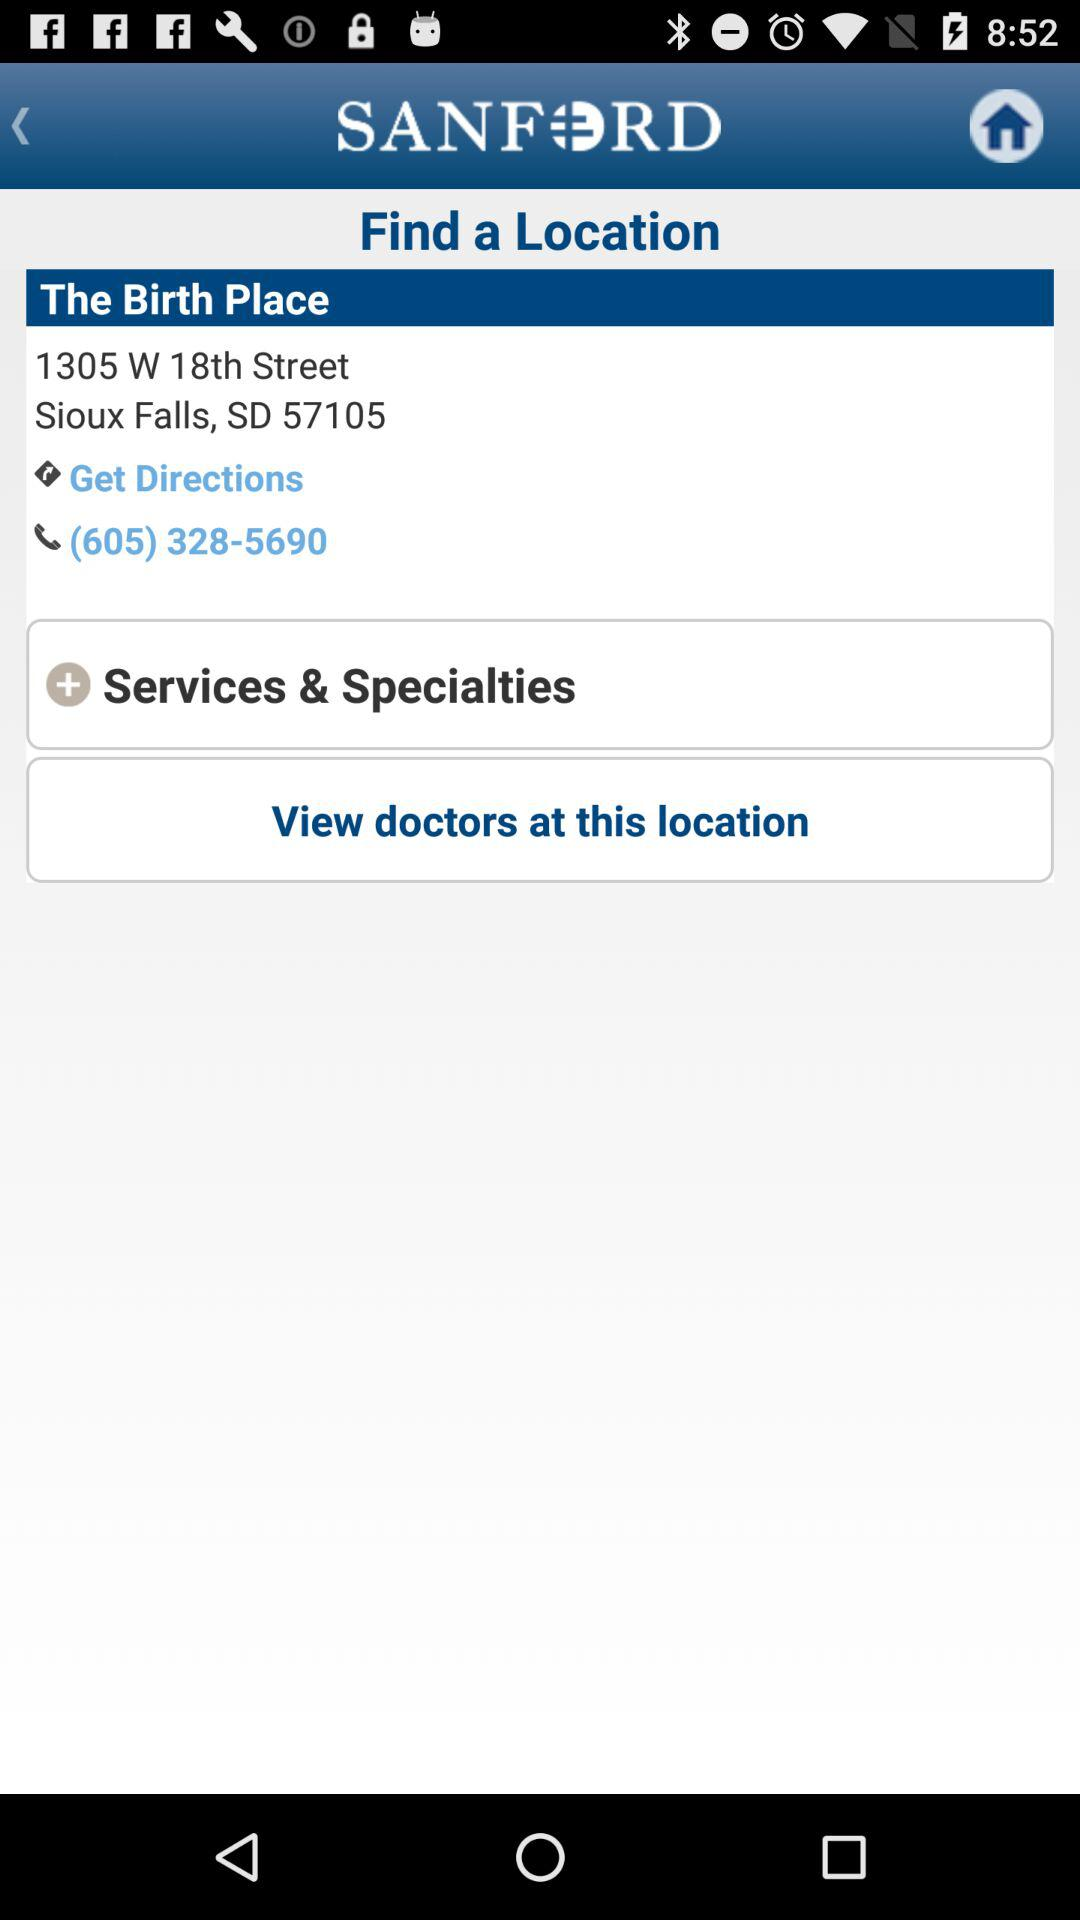What is the name of the center? The name of the center is "The Birth Place". 